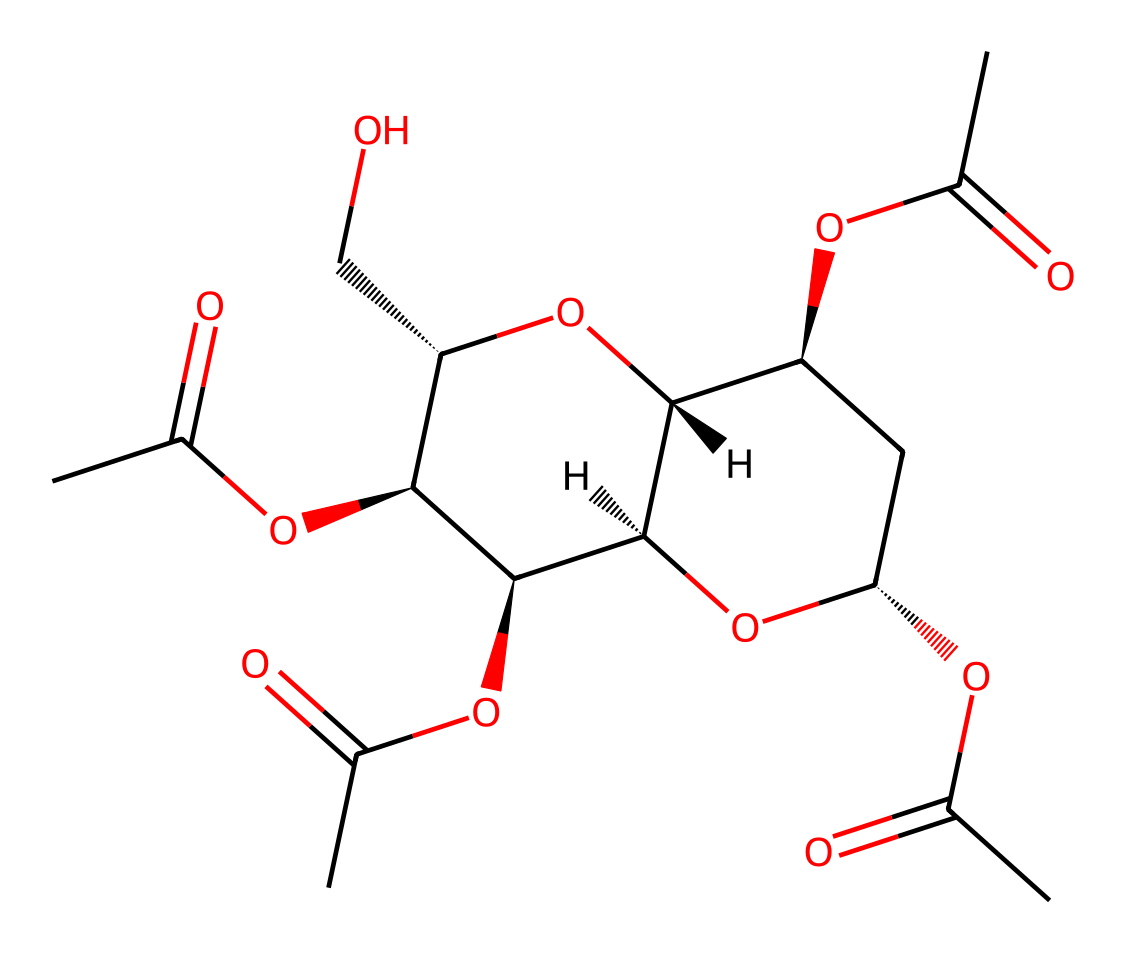What is the molecular formula of cellulose acetate? By analyzing the structure given in the SMILES representation, we can count the number of each type of atom present. The structure has 9 carbon (C) atoms, 10 hydrogen (H) atoms, and 6 oxygen (O) atoms, leading to the molecular formula C9H10O6.
Answer: C9H10O6 How many ester linkages are present in cellulose acetate? In the provided chemical structure, the presence of ester groups can be identified by the functional groups that involve a carbon linked to an oxygen and a carbonyl (C=O). Counting these linkages reveals 3 ester linkages.
Answer: 3 What type of polymer does cellulose acetate belong to? Cellulose acetate is derived from cellulose, a polysaccharide, through a chemical reaction to form an ester. This makes it a type of cellulose derivative, specifically a synthetic polymer.
Answer: synthetic polymer Is cellulose acetate biodegradable? Though it is derived from cellulose, cellulose acetate degrades more slowly than natural cellulose due to the modified chemical structure, which includes acetyl groups. Therefore, it is considered less biodegradable than natural polymers.
Answer: less biodegradable How does the presence of acetyl groups affect the solubility of cellulose acetate? The acetyl groups present in cellulose acetate increase its solubility in organic solvents while reducing its water solubility compared to natural cellulose, which is more hydrophilic due to its hydroxyl groups.
Answer: increases solubility in organic solvents 